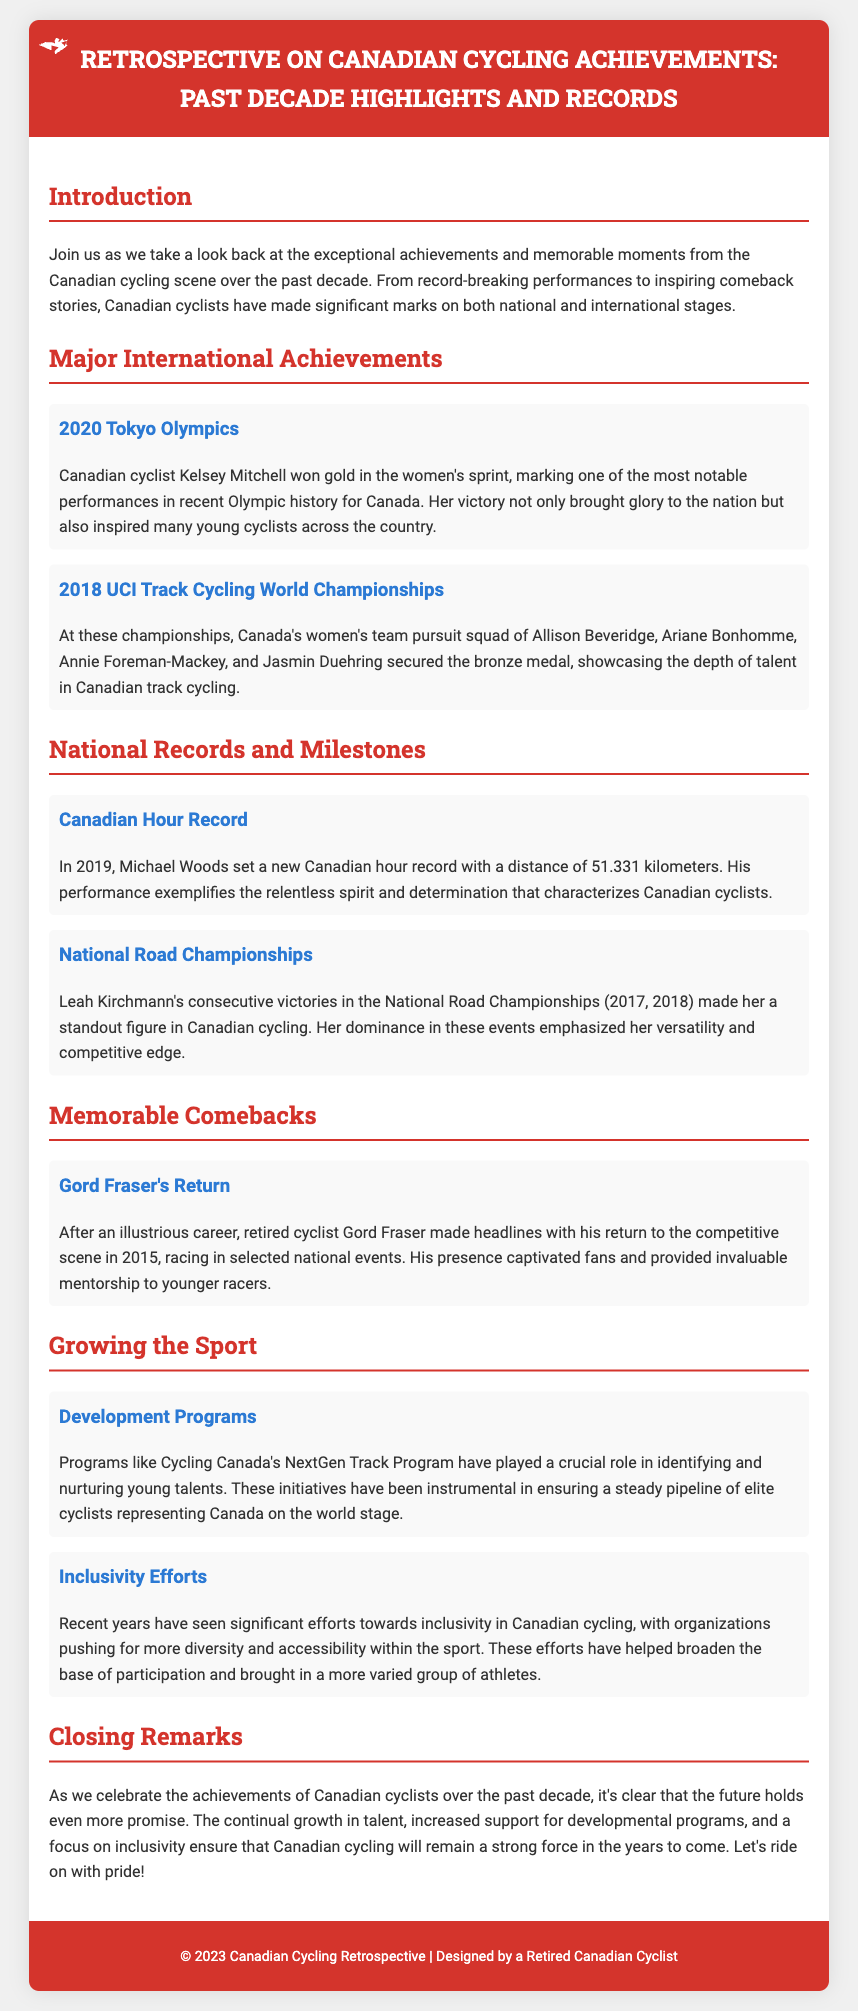What achievement did Kelsey Mitchell accomplish at the 2020 Tokyo Olympics? Kelsey Mitchell won gold in the women's sprint.
Answer: gold in the women's sprint What distance did Michael Woods set for the Canadian hour record? Michael Woods set a distance of 51.331 kilometers.
Answer: 51.331 kilometers Who were the members of Canada's women’s team pursuit squad at the 2018 UCI Track Cycling World Championships? The squad included Allison Beveridge, Ariane Bonhomme, Annie Foreman-Mackey, and Jasmin Duehring.
Answer: Allison Beveridge, Ariane Bonhomme, Annie Foreman-Mackey, Jasmin Duehring In what year did Leah Kirchmann win consecutive National Road Championships? Leah Kirchmann won consecutive championships in 2017 and 2018.
Answer: 2017, 2018 What is the name of the program that helps develop young cycling talents in Canada? The program is called Cycling Canada's NextGen Track Program.
Answer: Cycling Canada's NextGen Track Program What significant effort has been made towards inclusivity in Canadian cycling? Organizations are pushing for more diversity and accessibility within the sport.
Answer: More diversity and accessibility What year did Gord Fraser return to the competitive cycling scene? Gord Fraser made his return in 2015.
Answer: 2015 What is the main theme of the document? The document highlights Canadian cycling achievements over the past decade.
Answer: Canadian cycling achievements over the past decade What type of document is this? The document is a Playbill showcasing highlights and records of Canadian cycling.
Answer: Playbill 